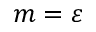<formula> <loc_0><loc_0><loc_500><loc_500>m = \varepsilon</formula> 